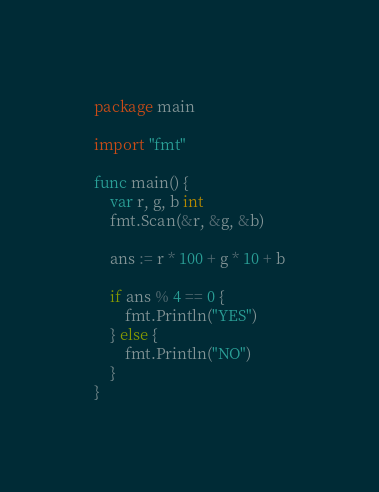Convert code to text. <code><loc_0><loc_0><loc_500><loc_500><_Go_>package main

import "fmt"

func main() {
	var r, g, b int
	fmt.Scan(&r, &g, &b)

	ans := r * 100 + g * 10 + b

	if ans % 4 == 0 {
		fmt.Println("YES")
	} else {
		fmt.Println("NO")
	}
}</code> 